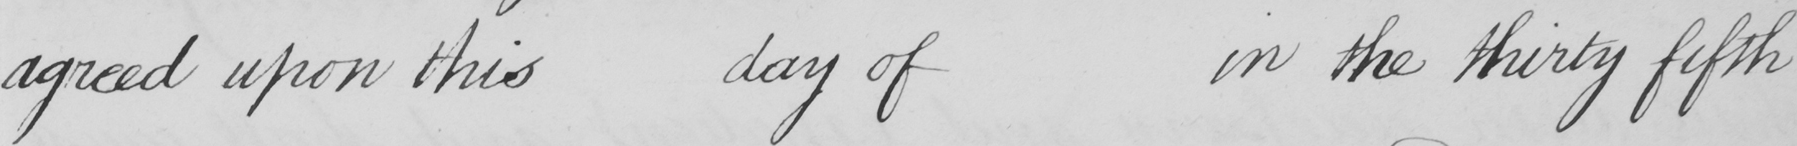Transcribe the text shown in this historical manuscript line. agreed upon this day of in the thirty fifth 